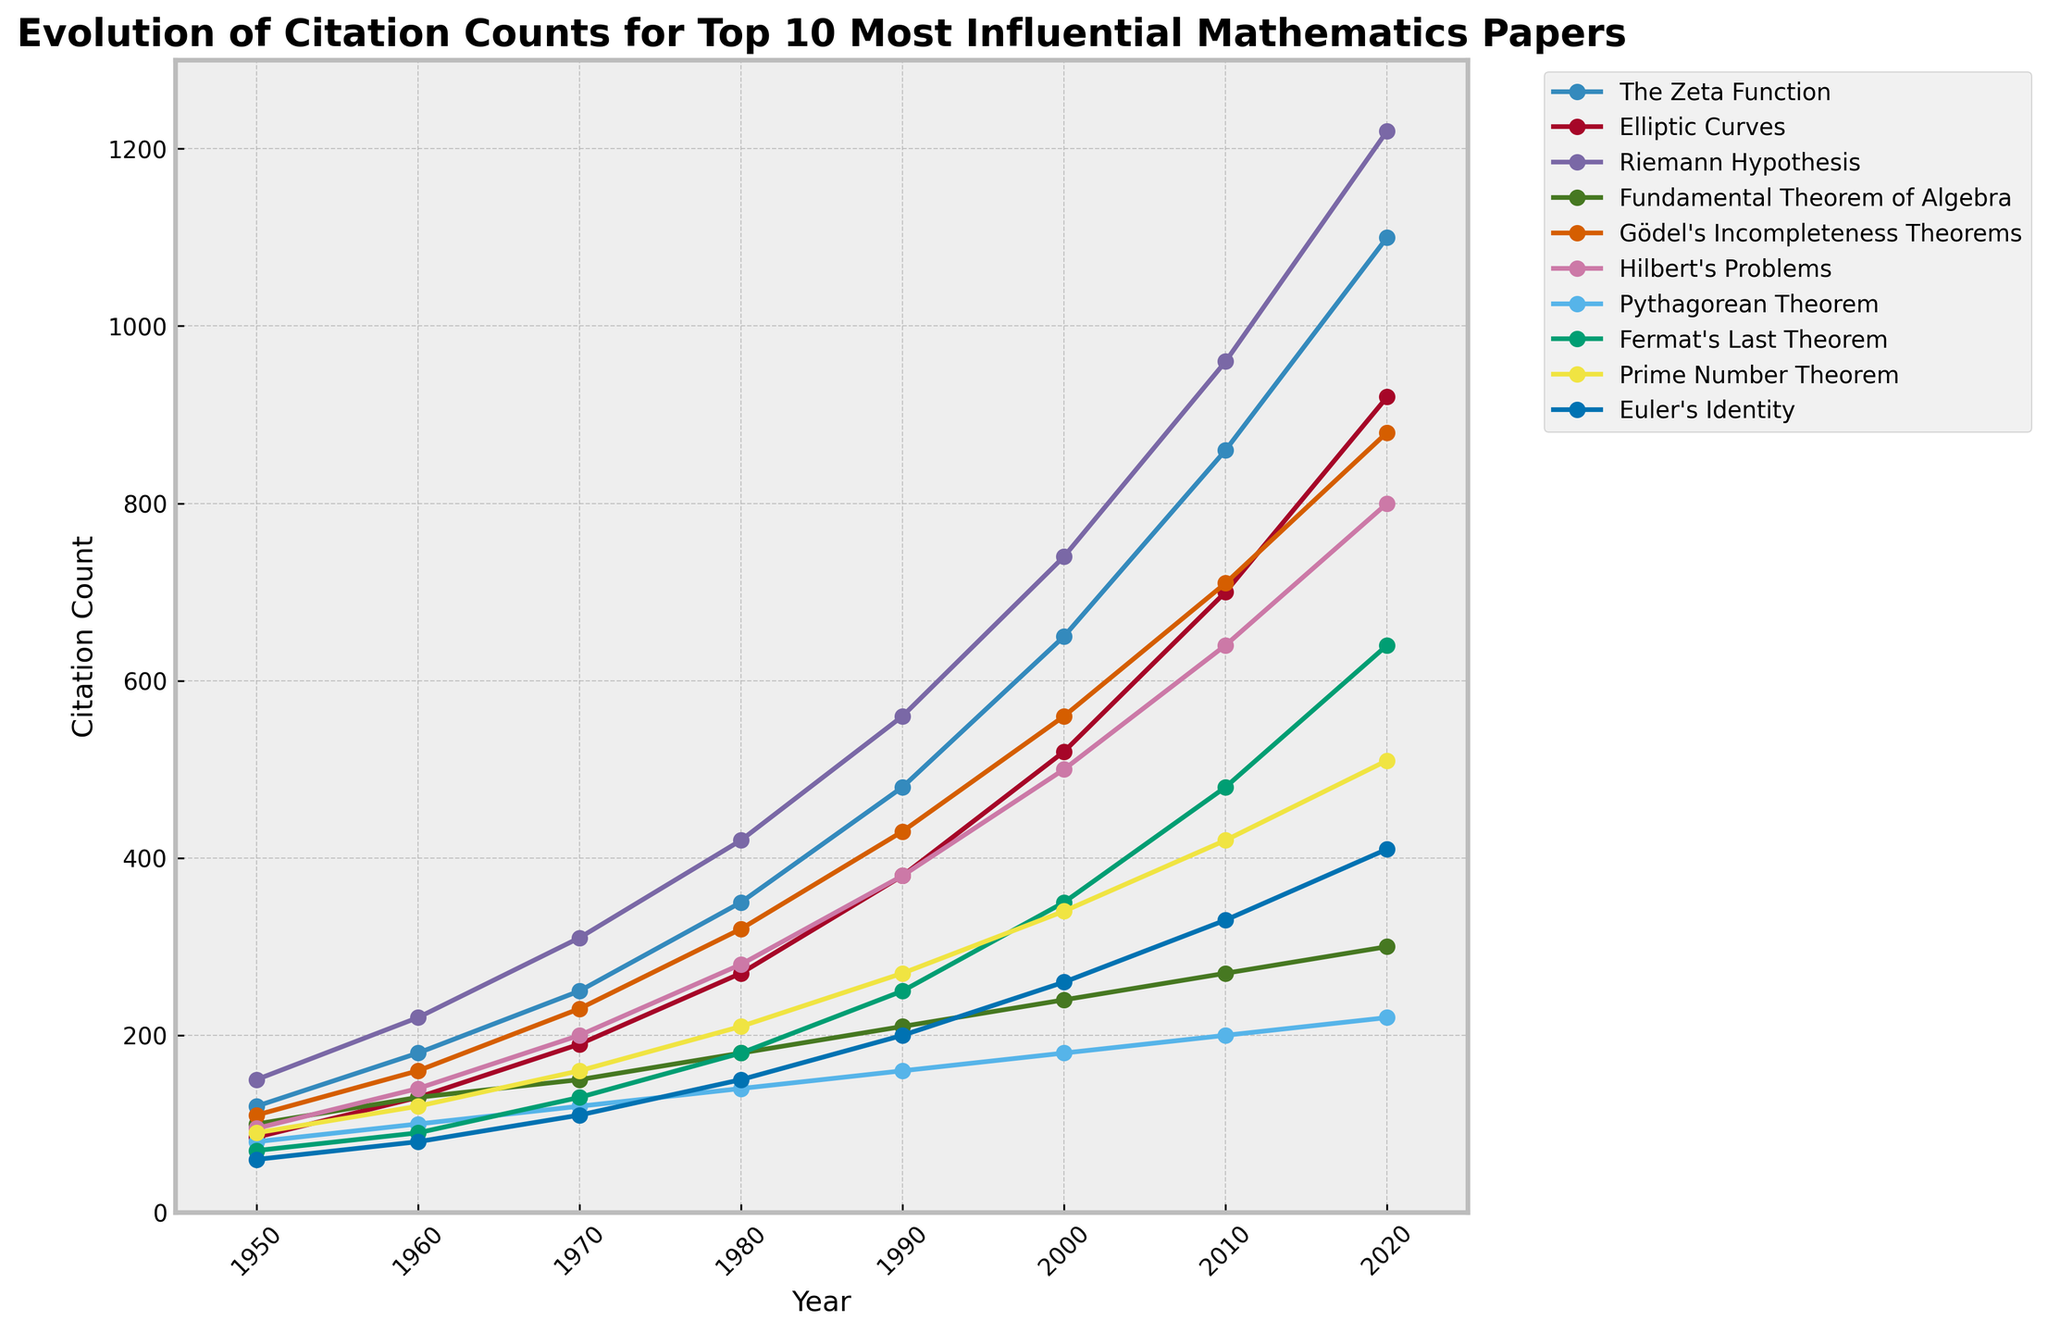Which paper has the highest citation count in 2020? Look at the citation counts for 2020 and identify the highest value. The highest citation count of 1220 corresponds to the Riemann Hypothesis.
Answer: Riemann Hypothesis How many more citations did the "Prime Number Theorem" receive in 2020 compared to 1950? Subtract the 1950 citation count for the Prime Number Theorem (90) from the 2020 citation count (510). 510 - 90 = 420
Answer: 420 Which two papers had the closest citation counts in 1990, and what were they? Examine the citation counts for 1990 and find the two values that are closest to each other. The Fundamental Theorem of Algebra (210) and Gödel's Incompleteness Theorems (430) are the closest, with a difference of 20 (430 - 210).
Answer: Fundamental Theorem of Algebra and Gödel's Incompleteness Theorems What is the average citation count for "The Zeta Function" over the years? Add up the citation counts for The Zeta Function across all years and divide by the number of years: (120 + 180 + 250 + 350 + 480 + 650 + 860 + 1100) / 8 = 1249.375
Answer: 499 In which decade did "Hilbert’s Problems" see the highest increase in citations? Calculate the difference in citation counts for each decade and identify the largest increase. The increase from 1970 (200) to 1980 (280) is 80, and the increase from 1990 (380) to 2000 (500) is 120. The largest increase is from 1990 to 2000.
Answer: 1990 to 2000 How many years did it take for the citations of "Elliptic Curves" to double from its 1970 count? Identify the citation count for Elliptic Curves in 1970 (190) and then find the year when it first doubled (380). This occurred in 1990. Therefore, it took 20 years (1990 - 1970).
Answer: 20 years Which paper had the smallest citation count in 1980? Look at the citation counts for 1980 and identify the smallest value (150), which corresponds to Euler’s Identity.
Answer: Euler’s Identity How much did the citation count for "Fermat's Last Theorem" increase from 1990 to 2010? Subtract the 1990 citation count for Fermat's Last Theorem (250) from the 2010 count (480), which results in an increase of 230 (480 - 250).
Answer: 230 By how much did the citation count for "Pythagorean Theorem" change from 1950 to 2020? Subtract the 1950 citation count for Pythagorean Theorem (80) from 2020 (220). The increase is 140 (220 - 80).
Answer: 140 